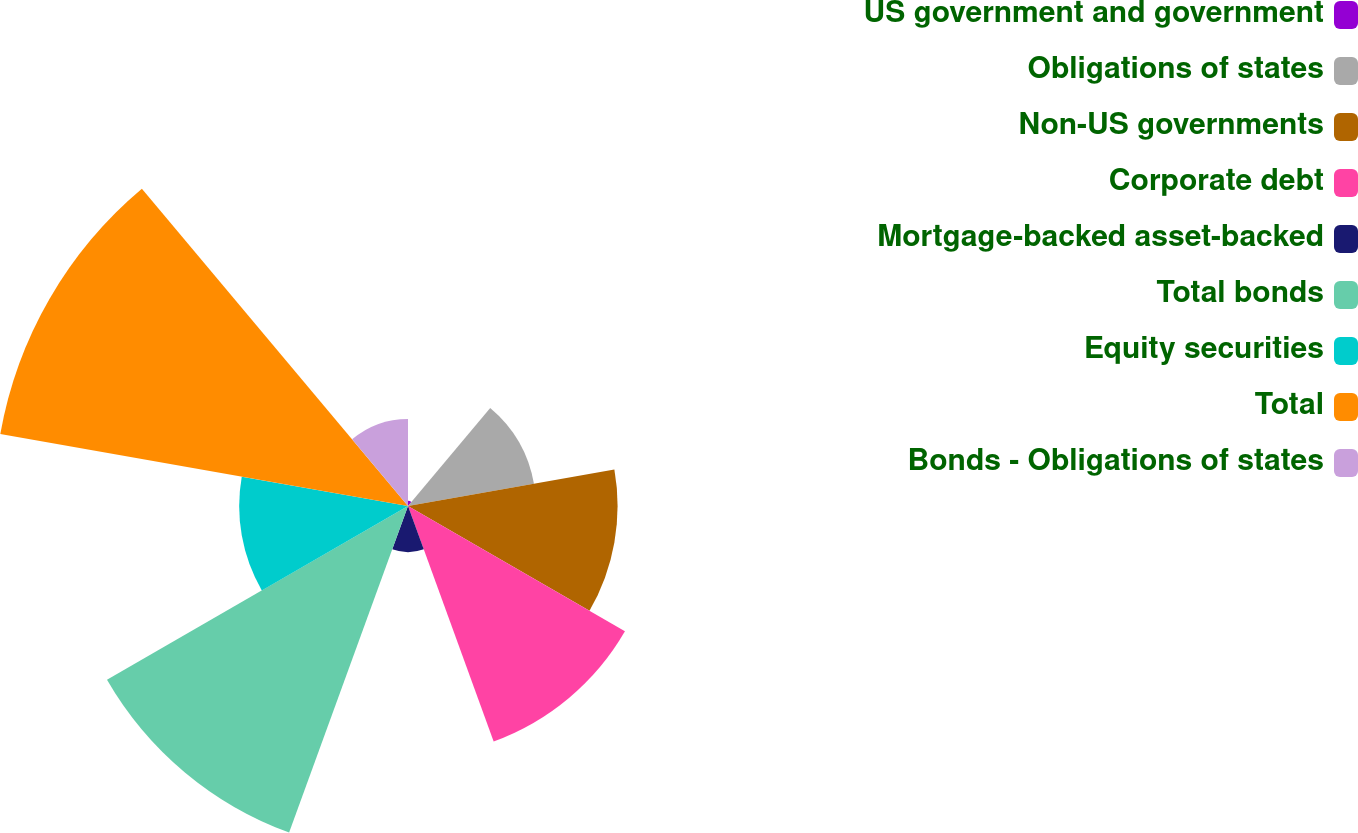Convert chart. <chart><loc_0><loc_0><loc_500><loc_500><pie_chart><fcel>US government and government<fcel>Obligations of states<fcel>Non-US governments<fcel>Corporate debt<fcel>Mortgage-backed asset-backed<fcel>Total bonds<fcel>Equity securities<fcel>Total<fcel>Bonds - Obligations of states<nl><fcel>0.32%<fcel>7.72%<fcel>12.65%<fcel>15.12%<fcel>2.78%<fcel>20.98%<fcel>10.19%<fcel>24.99%<fcel>5.25%<nl></chart> 